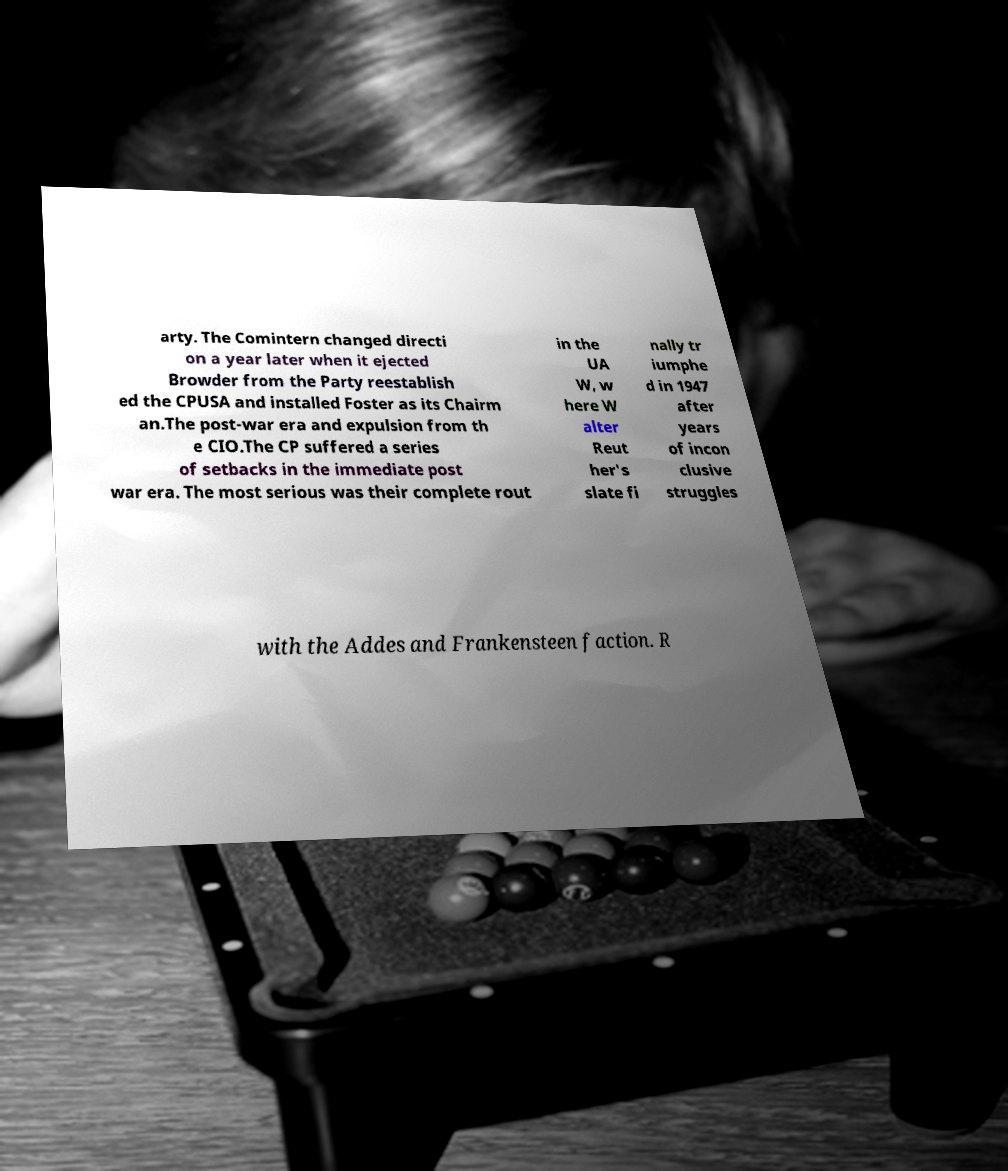I need the written content from this picture converted into text. Can you do that? arty. The Comintern changed directi on a year later when it ejected Browder from the Party reestablish ed the CPUSA and installed Foster as its Chairm an.The post-war era and expulsion from th e CIO.The CP suffered a series of setbacks in the immediate post war era. The most serious was their complete rout in the UA W, w here W alter Reut her's slate fi nally tr iumphe d in 1947 after years of incon clusive struggles with the Addes and Frankensteen faction. R 